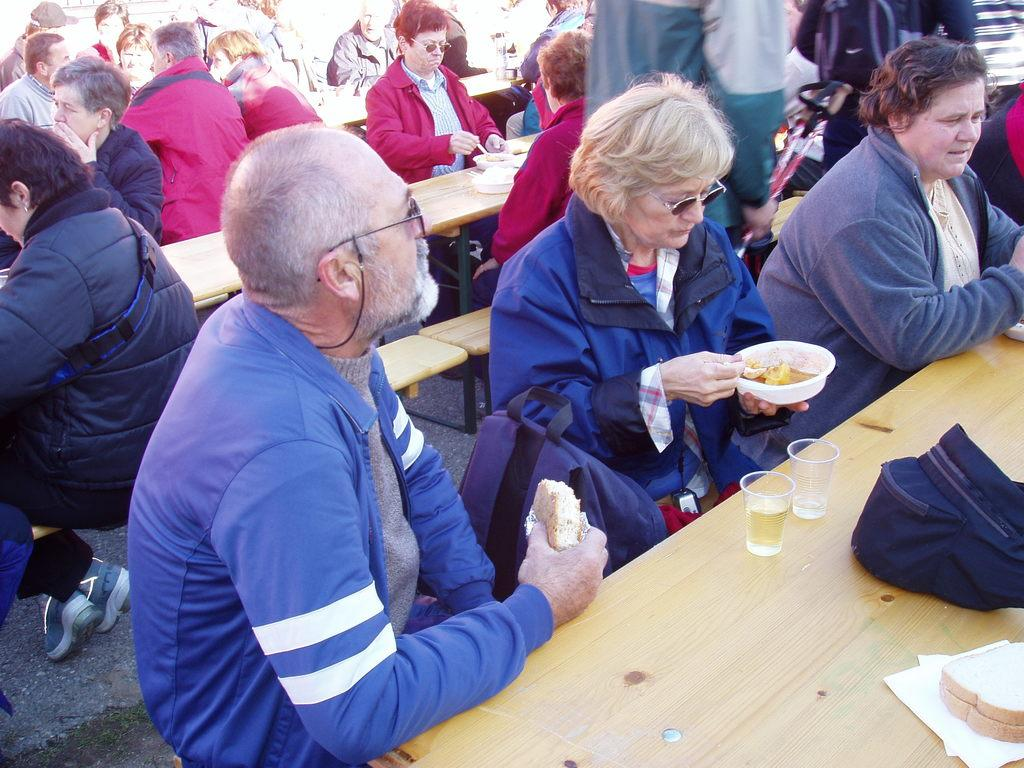What type of furniture is present in the image? There are tables and benches in the image. What are the people in the image doing? Some people are standing, and some are sitting in the image. What can be seen on the tables in the image? There is food visible on the tables in the image. What might the people be using to drink in the image? There are glasses in the image. What type of bucket is being used to collect rain in the image? There is no bucket or rain present in the image. How does the throat of the person sitting on the bench look in the image? The image does not show the throats of the people, so it cannot be determined from the image. 